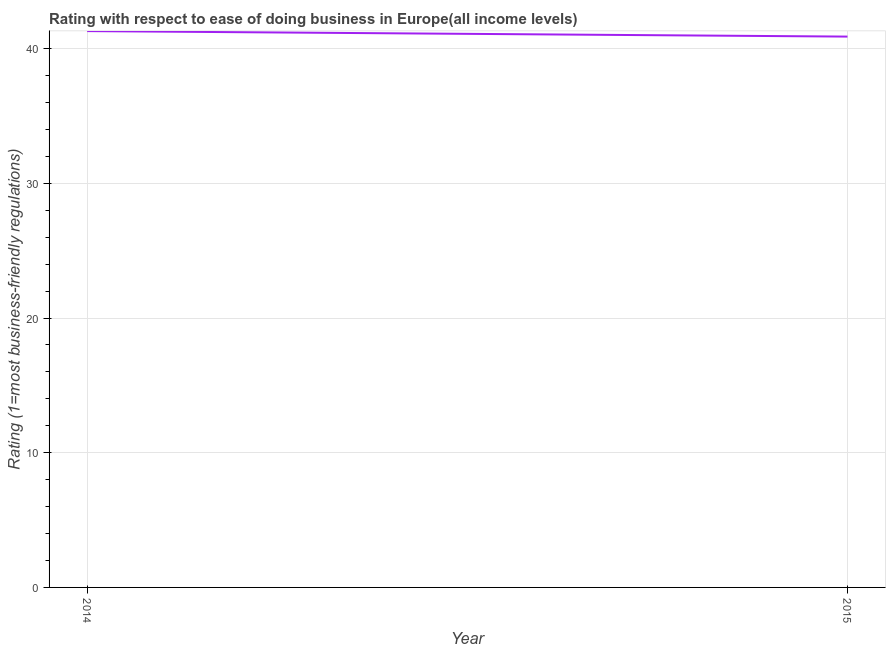What is the ease of doing business index in 2015?
Ensure brevity in your answer.  40.9. Across all years, what is the maximum ease of doing business index?
Keep it short and to the point. 41.31. Across all years, what is the minimum ease of doing business index?
Offer a terse response. 40.9. In which year was the ease of doing business index minimum?
Ensure brevity in your answer.  2015. What is the sum of the ease of doing business index?
Provide a succinct answer. 82.2. What is the difference between the ease of doing business index in 2014 and 2015?
Provide a short and direct response. 0.41. What is the average ease of doing business index per year?
Your answer should be compact. 41.1. What is the median ease of doing business index?
Ensure brevity in your answer.  41.1. What is the ratio of the ease of doing business index in 2014 to that in 2015?
Offer a very short reply. 1.01. Are the values on the major ticks of Y-axis written in scientific E-notation?
Make the answer very short. No. Does the graph contain any zero values?
Ensure brevity in your answer.  No. Does the graph contain grids?
Your answer should be compact. Yes. What is the title of the graph?
Ensure brevity in your answer.  Rating with respect to ease of doing business in Europe(all income levels). What is the label or title of the Y-axis?
Ensure brevity in your answer.  Rating (1=most business-friendly regulations). What is the Rating (1=most business-friendly regulations) in 2014?
Ensure brevity in your answer.  41.31. What is the Rating (1=most business-friendly regulations) in 2015?
Ensure brevity in your answer.  40.9. What is the difference between the Rating (1=most business-friendly regulations) in 2014 and 2015?
Offer a terse response. 0.41. 